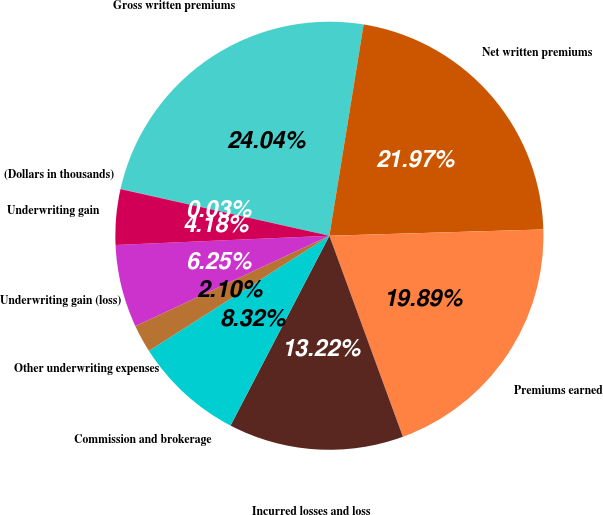<chart> <loc_0><loc_0><loc_500><loc_500><pie_chart><fcel>(Dollars in thousands)<fcel>Gross written premiums<fcel>Net written premiums<fcel>Premiums earned<fcel>Incurred losses and loss<fcel>Commission and brokerage<fcel>Other underwriting expenses<fcel>Underwriting gain (loss)<fcel>Underwriting gain<nl><fcel>0.03%<fcel>24.04%<fcel>21.97%<fcel>19.89%<fcel>13.22%<fcel>8.32%<fcel>2.1%<fcel>6.25%<fcel>4.18%<nl></chart> 